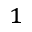Convert formula to latex. <formula><loc_0><loc_0><loc_500><loc_500>^ { 1 }</formula> 